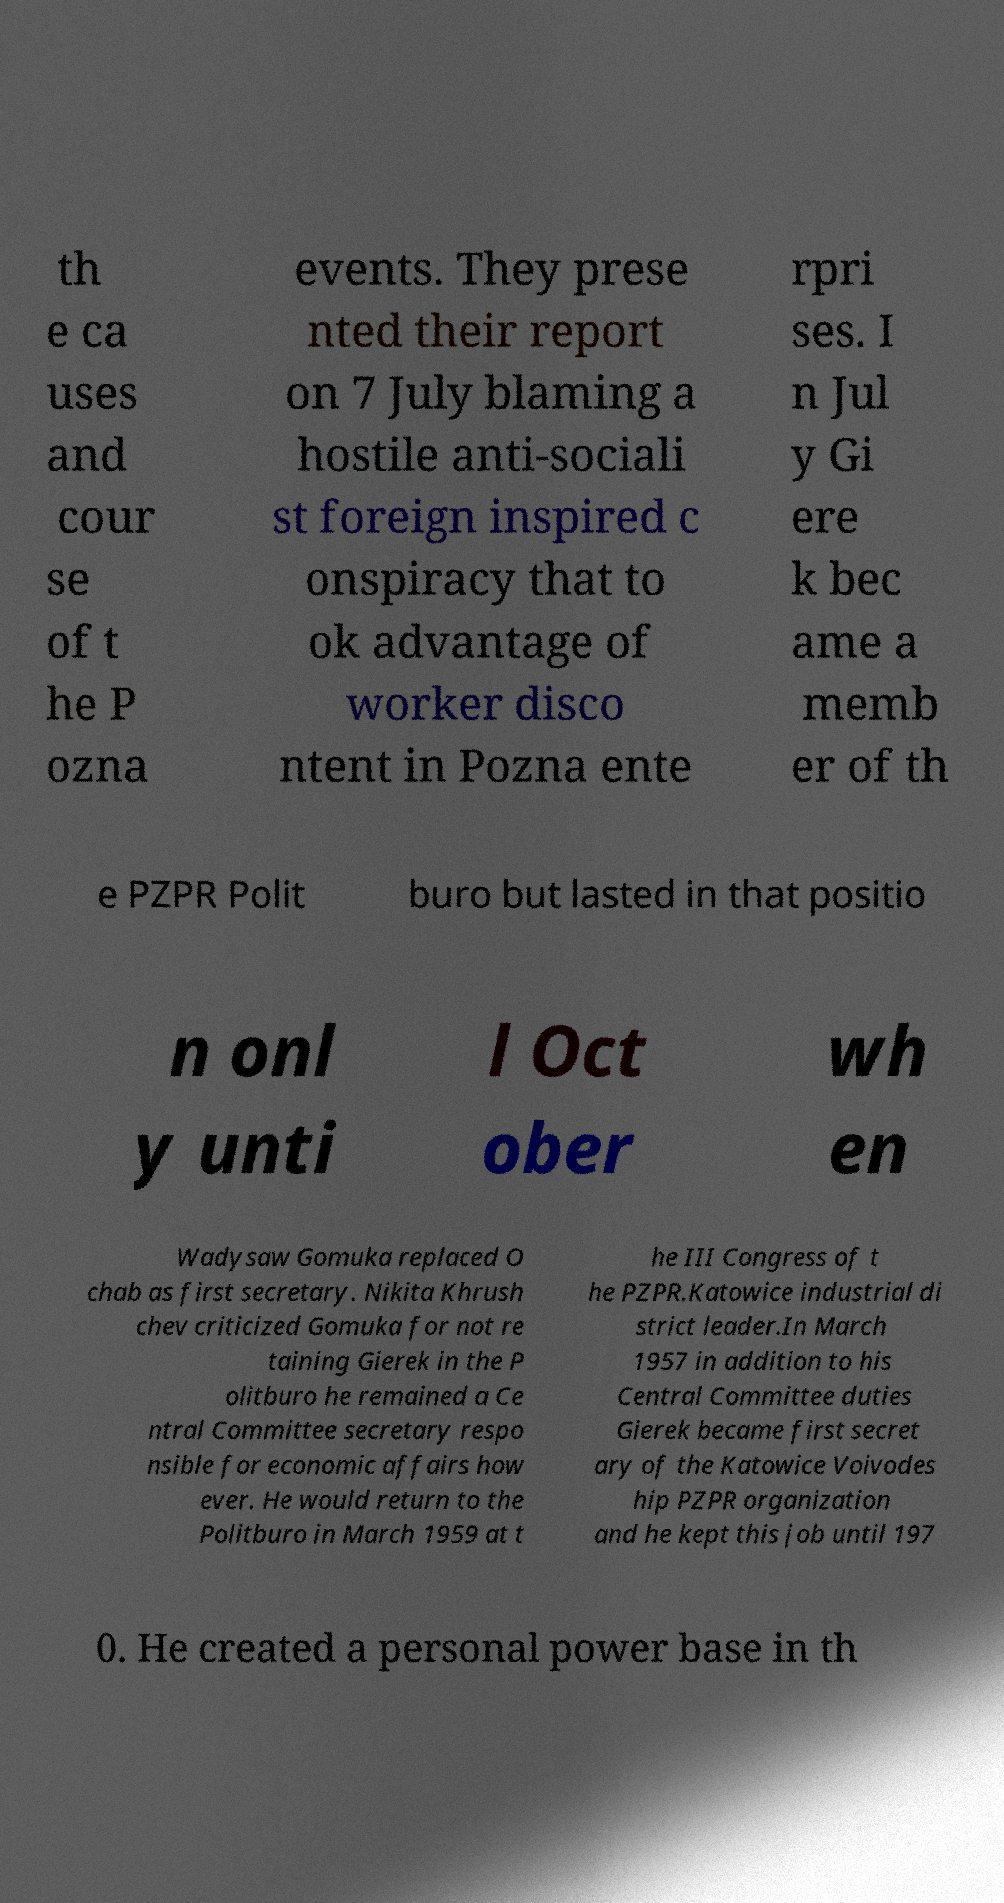I need the written content from this picture converted into text. Can you do that? th e ca uses and cour se of t he P ozna events. They prese nted their report on 7 July blaming a hostile anti-sociali st foreign inspired c onspiracy that to ok advantage of worker disco ntent in Pozna ente rpri ses. I n Jul y Gi ere k bec ame a memb er of th e PZPR Polit buro but lasted in that positio n onl y unti l Oct ober wh en Wadysaw Gomuka replaced O chab as first secretary. Nikita Khrush chev criticized Gomuka for not re taining Gierek in the P olitburo he remained a Ce ntral Committee secretary respo nsible for economic affairs how ever. He would return to the Politburo in March 1959 at t he III Congress of t he PZPR.Katowice industrial di strict leader.In March 1957 in addition to his Central Committee duties Gierek became first secret ary of the Katowice Voivodes hip PZPR organization and he kept this job until 197 0. He created a personal power base in th 